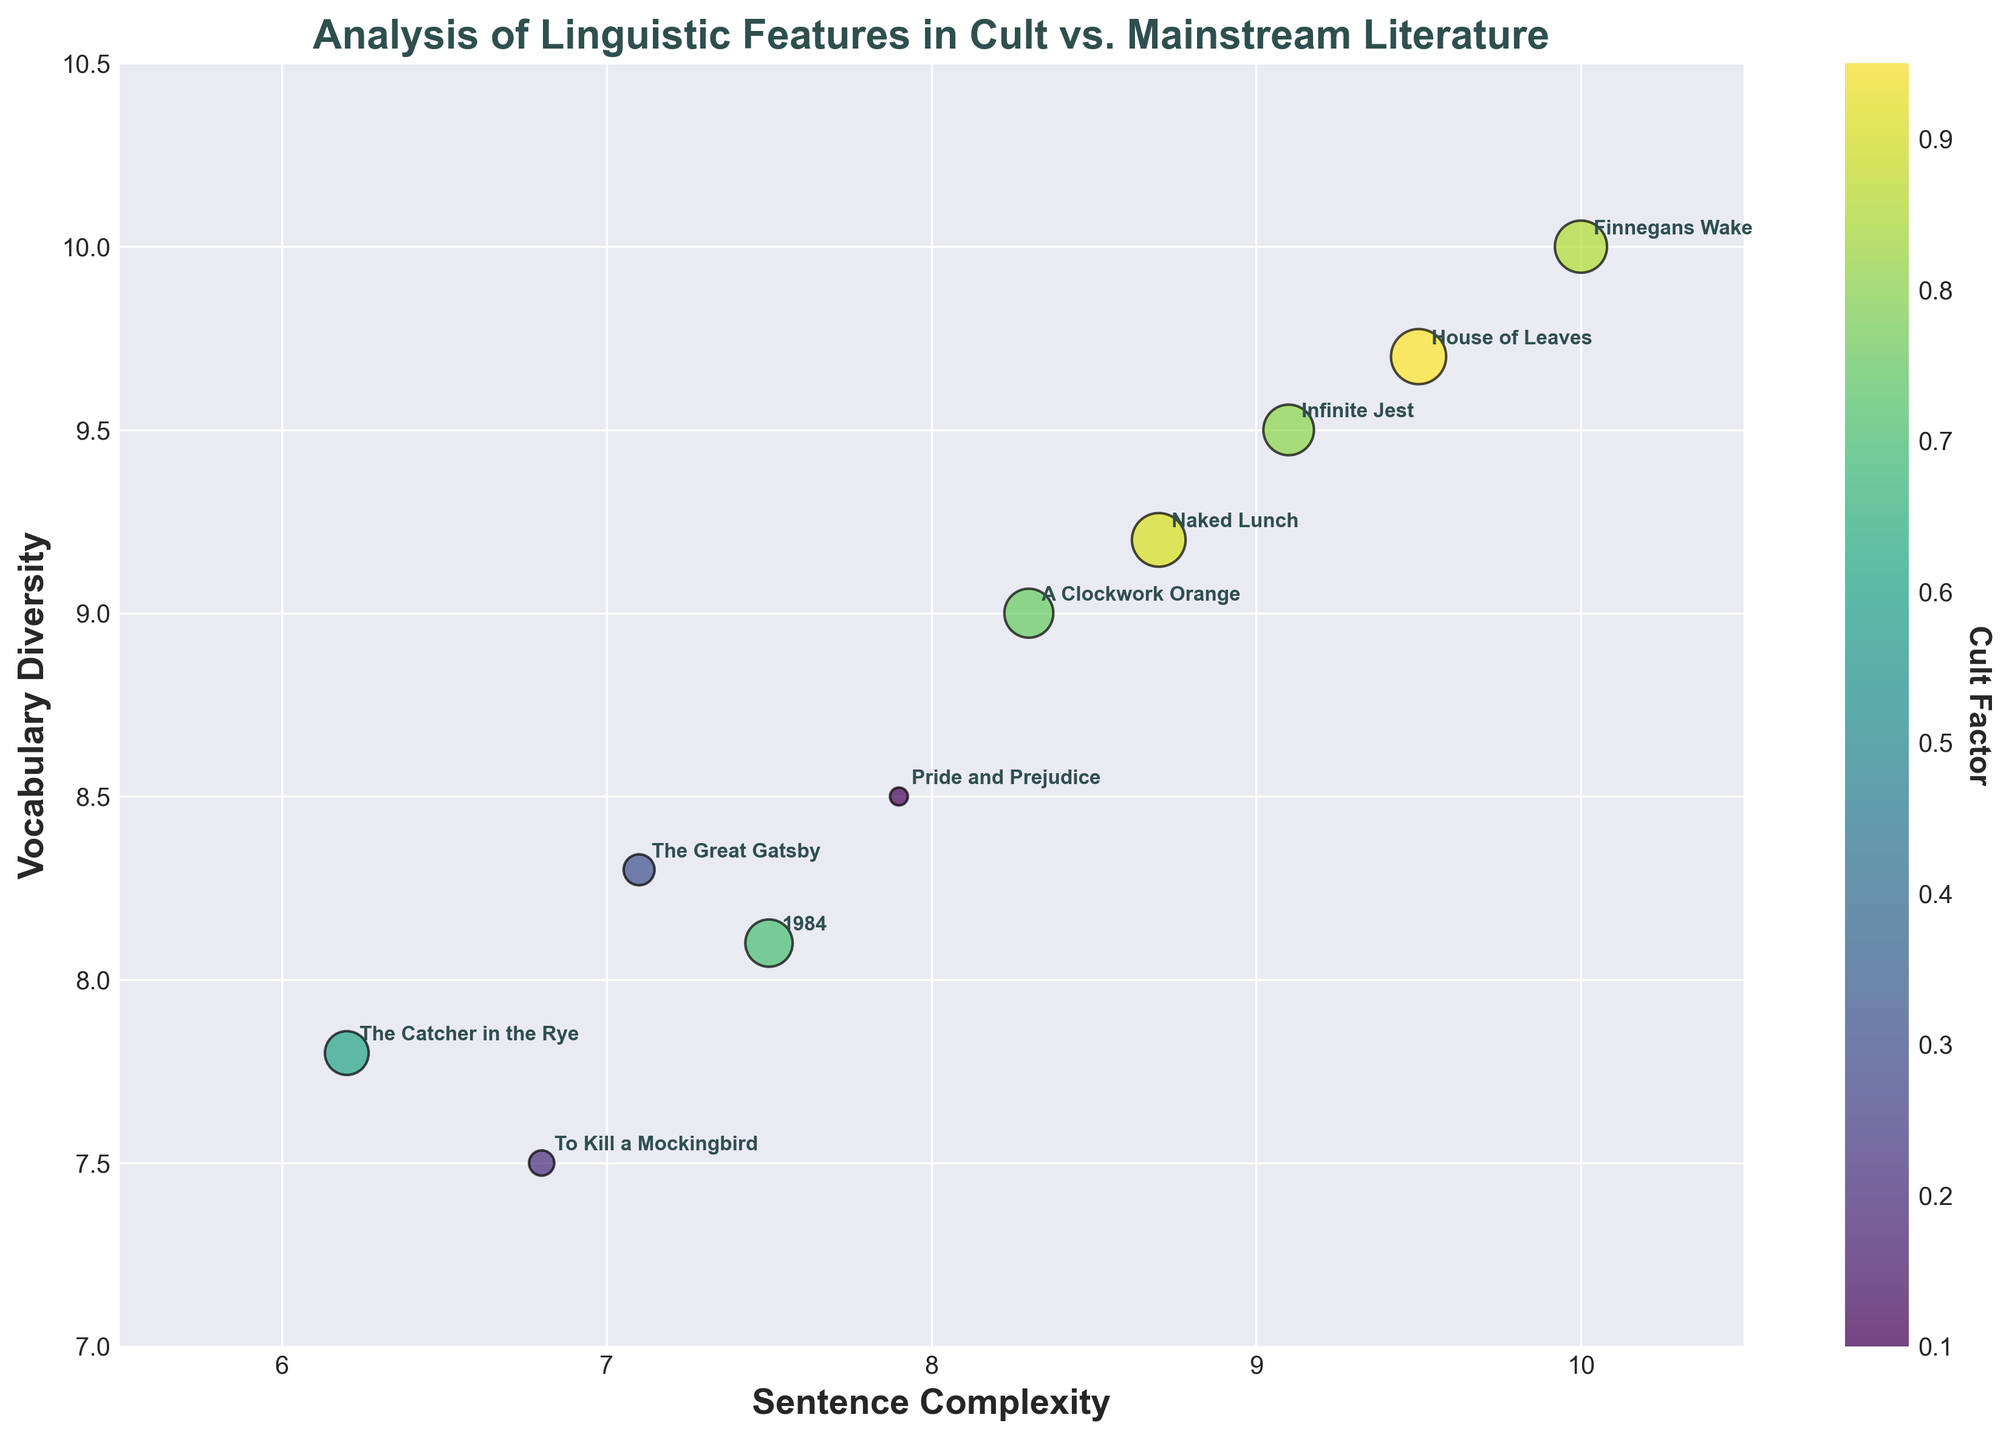What is the title of the figure? The title of the figure is prominently displayed at the top. It reads "Analysis of Linguistic Features in Cult vs. Mainstream Literature".
Answer: Analysis of Linguistic Features in Cult vs. Mainstream Literature Which book has the highest sentence complexity and vocabulary diversity? By examining the upper-right corner of the figure, the book title located at the highest coordinates (10, 10) for both sentence complexity and vocabulary diversity is "Finnegans Wake".
Answer: Finnegans Wake What do the colors represent in the figure? The colors of the data points correspond to the "Cult Factor", which is indicated by the color bar located next to the plot. The range of colors from the colormap (viridis) represents different levels of cult factor.
Answer: Cult Factor Which book has the lowest cult factor in the figure? The color bar shows the range of the cult factor, and the points with the lowest value will be in the lighter colors. "Pride and Prejudice" stands out as being at the lower end with a cult factor of 0.1.
Answer: Pride and Prejudice How many books have a cult factor greater than 0.8? By looking at the color intensity and cross-referencing with the figure, we see "Naked Lunch", "House of Leaves", "Finnegans Wake", and "Infinite Jest" all have cult factors greater than 0.8. This totals to four books.
Answer: Four Compare the sentence complexity and vocabulary diversity of "The Great Gatsby" and "1984". Which book has higher values? "The Great Gatsby" has a sentence complexity of 7.1 and vocabulary diversity of 8.3. "1984" has a sentence complexity of 7.5 and vocabulary diversity of 8.1. Thus, "The Great Gatsby" has a higher vocabulary diversity, but "1984" has a higher sentence complexity.
Answer: The Great Gatsby has higher vocabulary diversity; 1984 has higher sentence complexity What are the axis labels and what do they represent? The x-axis is labeled "Sentence Complexity" and the y-axis is labeled "Vocabulary Diversity". These labels represent the two main linguistic features being analyzed in the figure.
Answer: Sentence Complexity and Vocabulary Diversity Which two books are closest in terms of sentence complexity and vocabulary diversity? By visually inspecting the plot, "The Catcher in the Rye" and "To Kill a Mockingbird" are closest, both having relatively close coordinates (approx. 6.2, 7.8) and (approx. 6.8, 7.5) respectively.
Answer: The Catcher in the Rye and To Kill a Mockingbird Compare the cult factor of "A Clockwork Orange" and "Infinite Jest". Which book has a higher cult factor? By referencing the annotated colors and comparing their cult factor sizes, "Infinite Jest" has a cult factor of 0.8, whereas "A Clockwork Orange" has a cult factor of 0.75. Therefore, "Infinite Jest" has a higher cult factor.
Answer: Infinite Jest What is the average sentence complexity of "House of Leaves" and "Naked Lunch"? The sentence complexity for "House of Leaves" is 9.5 and for "Naked Lunch" is 8.7. Summing these values yields 18.2, and the average is 18.2/2 = 9.1.
Answer: 9.1 